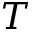<formula> <loc_0><loc_0><loc_500><loc_500>T</formula> 